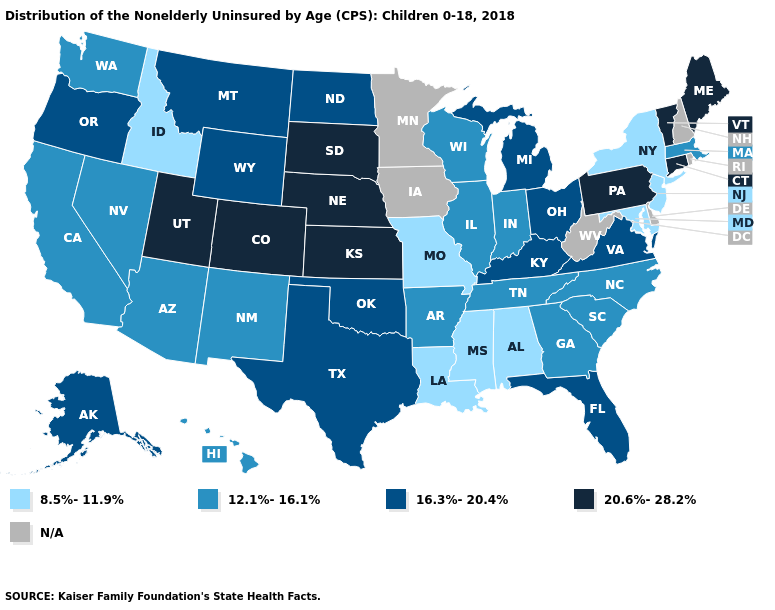What is the value of Virginia?
Write a very short answer. 16.3%-20.4%. Among the states that border Georgia , does Alabama have the highest value?
Be succinct. No. Name the states that have a value in the range 12.1%-16.1%?
Concise answer only. Arizona, Arkansas, California, Georgia, Hawaii, Illinois, Indiana, Massachusetts, Nevada, New Mexico, North Carolina, South Carolina, Tennessee, Washington, Wisconsin. How many symbols are there in the legend?
Be succinct. 5. Which states have the lowest value in the USA?
Give a very brief answer. Alabama, Idaho, Louisiana, Maryland, Mississippi, Missouri, New Jersey, New York. What is the highest value in the USA?
Keep it brief. 20.6%-28.2%. Does the first symbol in the legend represent the smallest category?
Be succinct. Yes. Which states have the lowest value in the Northeast?
Keep it brief. New Jersey, New York. What is the lowest value in the USA?
Answer briefly. 8.5%-11.9%. What is the lowest value in states that border Rhode Island?
Write a very short answer. 12.1%-16.1%. Name the states that have a value in the range 8.5%-11.9%?
Answer briefly. Alabama, Idaho, Louisiana, Maryland, Mississippi, Missouri, New Jersey, New York. Which states have the highest value in the USA?
Give a very brief answer. Colorado, Connecticut, Kansas, Maine, Nebraska, Pennsylvania, South Dakota, Utah, Vermont. 